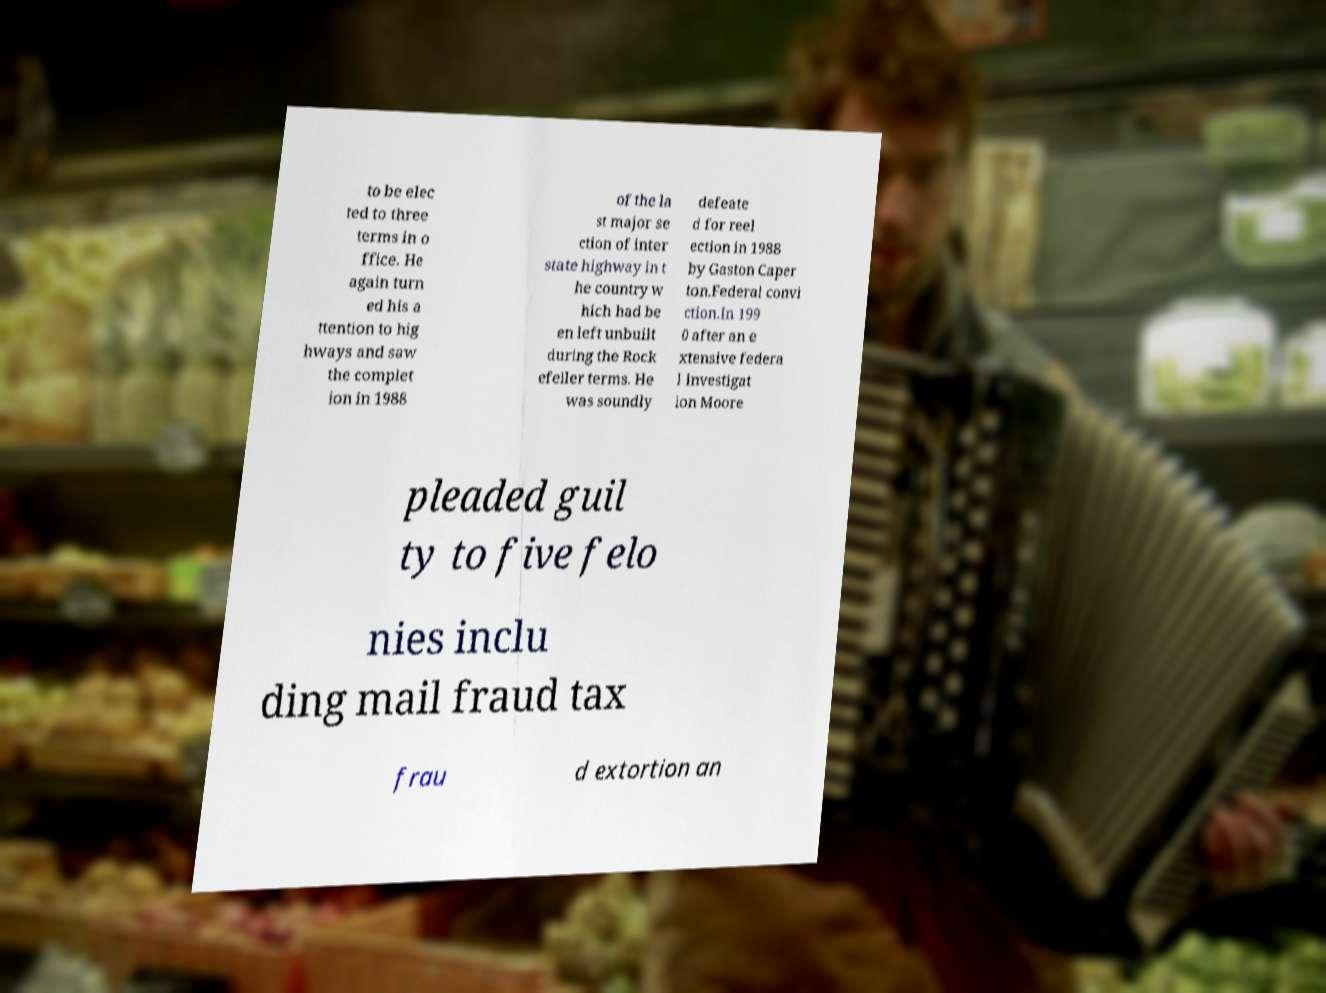I need the written content from this picture converted into text. Can you do that? to be elec ted to three terms in o ffice. He again turn ed his a ttention to hig hways and saw the complet ion in 1988 of the la st major se ction of inter state highway in t he country w hich had be en left unbuilt during the Rock efeller terms. He was soundly defeate d for reel ection in 1988 by Gaston Caper ton.Federal convi ction.In 199 0 after an e xtensive federa l investigat ion Moore pleaded guil ty to five felo nies inclu ding mail fraud tax frau d extortion an 